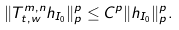Convert formula to latex. <formula><loc_0><loc_0><loc_500><loc_500>\| T ^ { m , n } _ { t , w } h _ { I _ { 0 } } \| ^ { p } _ { p } \leq C ^ { p } \| h _ { I _ { 0 } } \| ^ { p } _ { p } .</formula> 